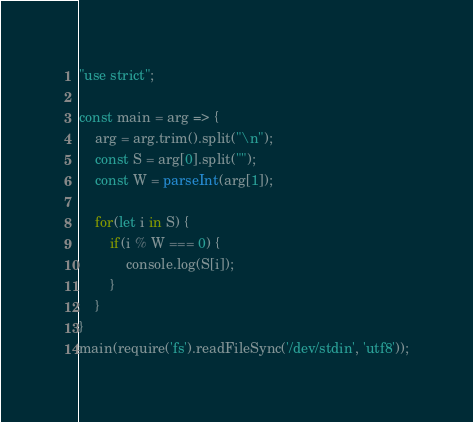<code> <loc_0><loc_0><loc_500><loc_500><_JavaScript_>"use strict";
    
const main = arg => {
    arg = arg.trim().split("\n");
    const S = arg[0].split("");
    const W = parseInt(arg[1]);
    
    for(let i in S) {
        if(i % W === 0) {
            console.log(S[i]);
        }
    }
}
main(require('fs').readFileSync('/dev/stdin', 'utf8'));</code> 